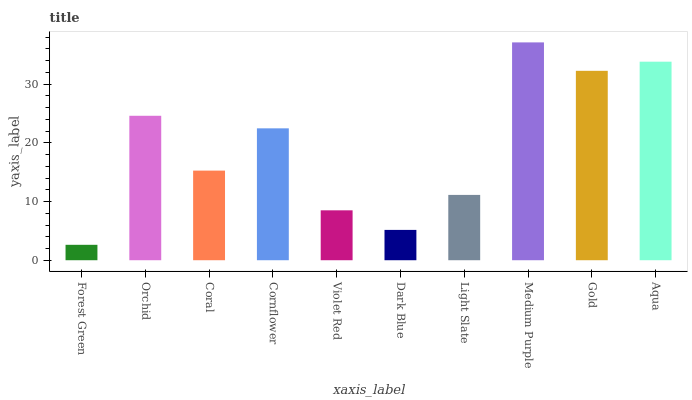Is Orchid the minimum?
Answer yes or no. No. Is Orchid the maximum?
Answer yes or no. No. Is Orchid greater than Forest Green?
Answer yes or no. Yes. Is Forest Green less than Orchid?
Answer yes or no. Yes. Is Forest Green greater than Orchid?
Answer yes or no. No. Is Orchid less than Forest Green?
Answer yes or no. No. Is Cornflower the high median?
Answer yes or no. Yes. Is Coral the low median?
Answer yes or no. Yes. Is Medium Purple the high median?
Answer yes or no. No. Is Light Slate the low median?
Answer yes or no. No. 